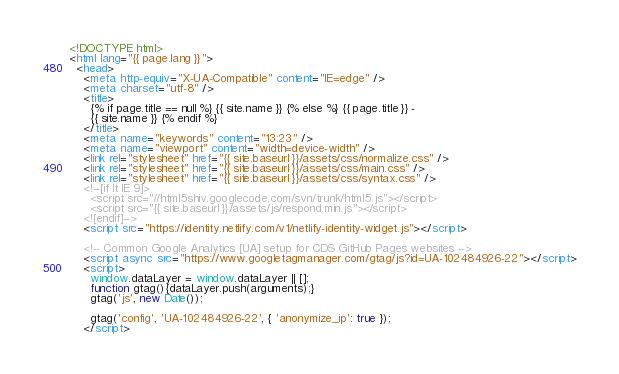Convert code to text. <code><loc_0><loc_0><loc_500><loc_500><_HTML_><!DOCTYPE html>
<html lang="{{ page.lang }}">
  <head>
    <meta http-equiv="X-UA-Compatible" content="IE=edge" />
    <meta charset="utf-8" />
    <title>
      {% if page.title == null %} {{ site.name }} {% else %} {{ page.title }} -
      {{ site.name }} {% endif %}
    </title>
    <meta name="keywords" content="13:23" />
    <meta name="viewport" content="width=device-width" />
    <link rel="stylesheet" href="{{ site.baseurl }}/assets/css/normalize.css" />
    <link rel="stylesheet" href="{{ site.baseurl }}/assets/css/main.css" />
    <link rel="stylesheet" href="{{ site.baseurl }}/assets/css/syntax.css" />
    <!--[if lt IE 9]>
      <script src="//html5shiv.googlecode.com/svn/trunk/html5.js"></script>
      <script src="{{ site.baseurl }}/assets/js/respond.min.js"></script>
    <![endif]-->
    <script src="https://identity.netlify.com/v1/netlify-identity-widget.js"></script>

    <!-- Common Google Analytics [UA] setup for CDS GitHub Pages websites -->
    <script async src="https://www.googletagmanager.com/gtag/js?id=UA-102484926-22"></script>
    <script>
      window.dataLayer = window.dataLayer || [];
      function gtag(){dataLayer.push(arguments);}
      gtag('js', new Date());

      gtag('config', 'UA-102484926-22', { 'anonymize_ip': true });
    </script></code> 